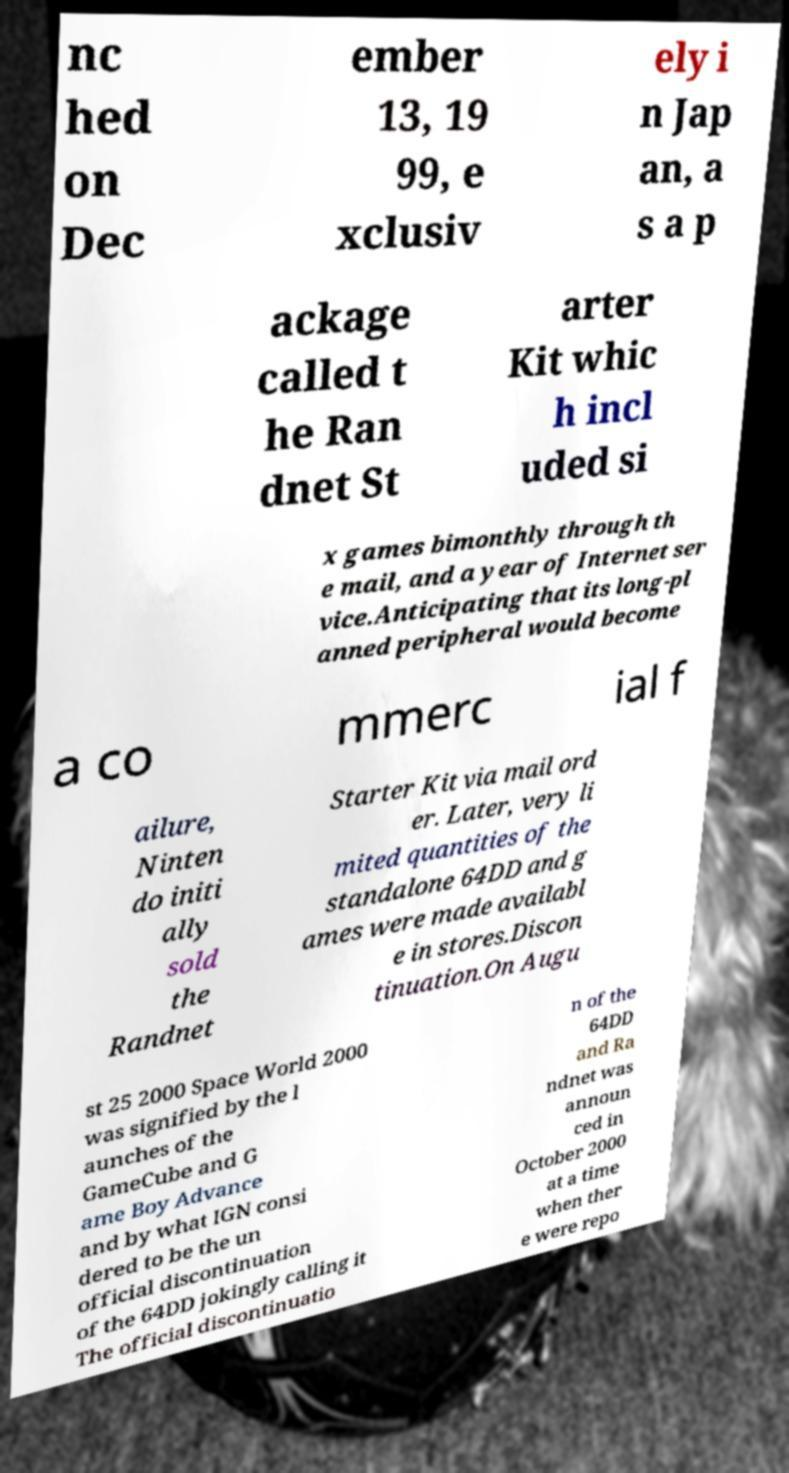There's text embedded in this image that I need extracted. Can you transcribe it verbatim? nc hed on Dec ember 13, 19 99, e xclusiv ely i n Jap an, a s a p ackage called t he Ran dnet St arter Kit whic h incl uded si x games bimonthly through th e mail, and a year of Internet ser vice.Anticipating that its long-pl anned peripheral would become a co mmerc ial f ailure, Ninten do initi ally sold the Randnet Starter Kit via mail ord er. Later, very li mited quantities of the standalone 64DD and g ames were made availabl e in stores.Discon tinuation.On Augu st 25 2000 Space World 2000 was signified by the l aunches of the GameCube and G ame Boy Advance and by what IGN consi dered to be the un official discontinuation of the 64DD jokingly calling it The official discontinuatio n of the 64DD and Ra ndnet was announ ced in October 2000 at a time when ther e were repo 